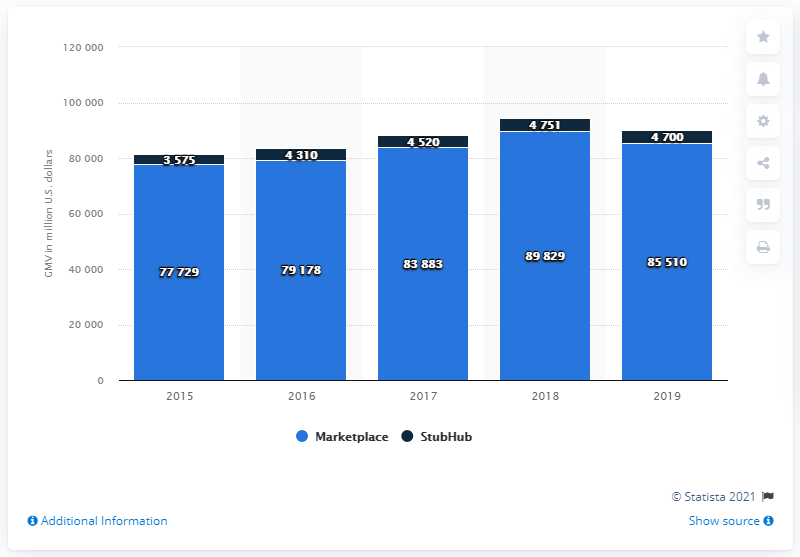Specify some key components in this picture. eBay's overall GMV amounted to $89,829 in dollars in 2021. In the most recent fiscal period, eBay's Marketplace segment achieved a GMV of $85,510. 